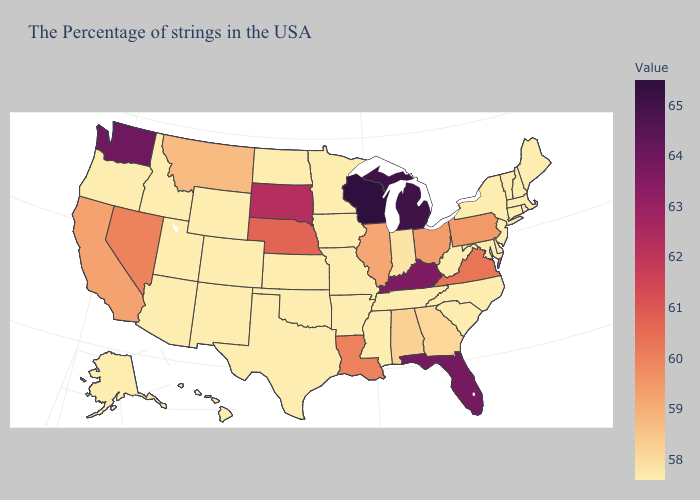Which states have the highest value in the USA?
Answer briefly. Wisconsin. Among the states that border Nebraska , which have the highest value?
Answer briefly. South Dakota. Among the states that border Iowa , does Illinois have the highest value?
Answer briefly. No. Does Kentucky have the lowest value in the USA?
Quick response, please. No. Among the states that border Michigan , does Wisconsin have the lowest value?
Concise answer only. No. 